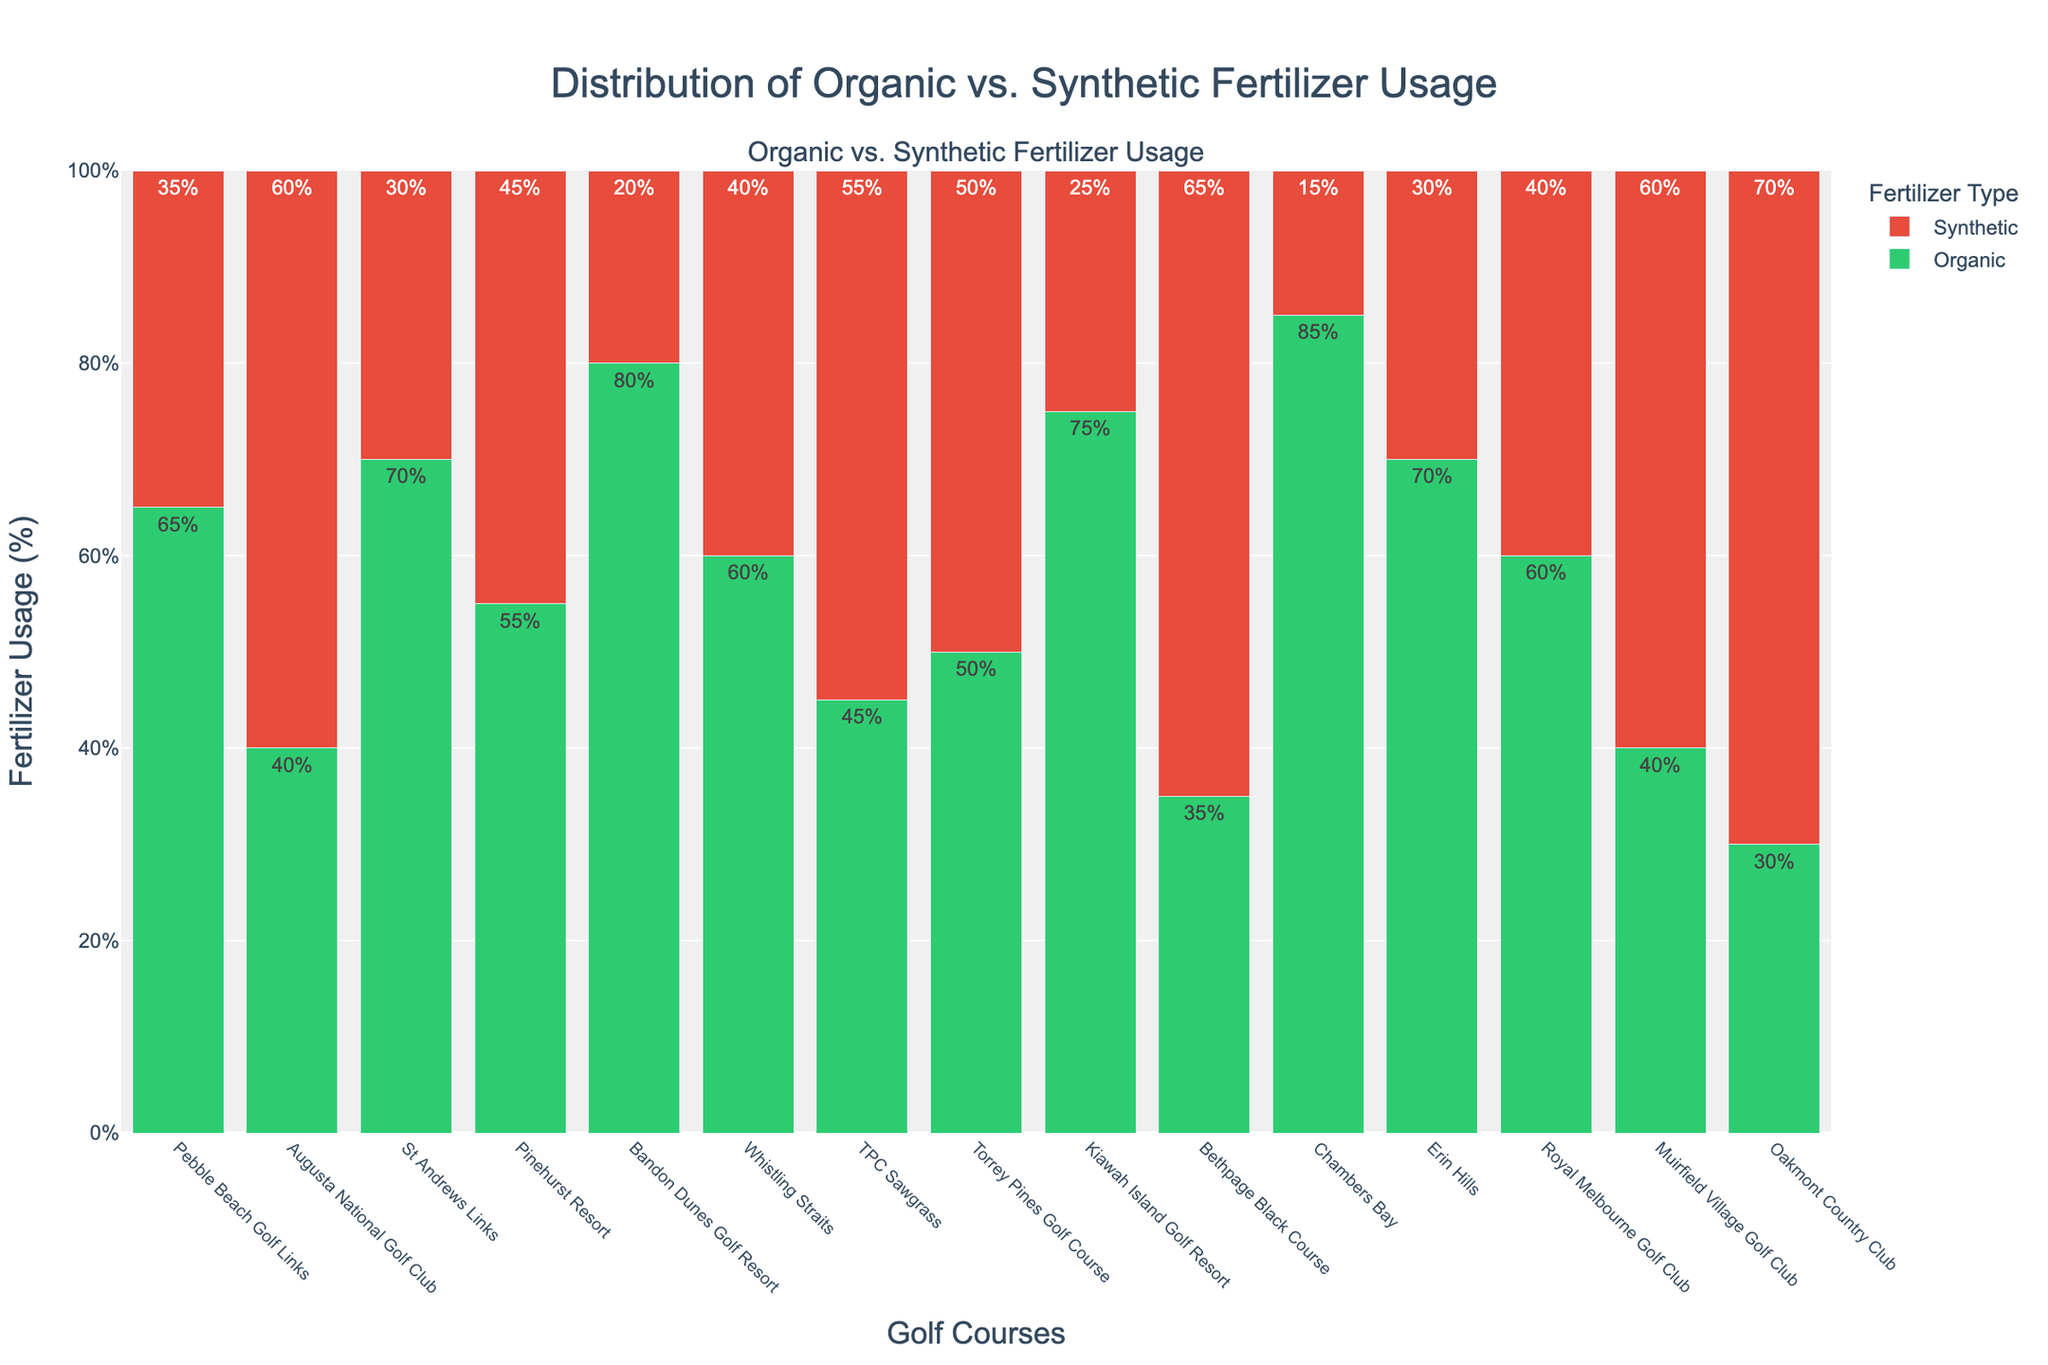What percentage of fertilizer used at Pebble Beach Golf Links is organic? The green bar for Pebble Beach Golf Links indicates that the percentage of organic fertilizer used is 65%.
Answer: 65% Which golf course uses the most synthetic fertilizer? By comparing the height of the red bars, Oakmont Country Club has the tallest red bar, indicating it uses the most synthetic fertilizer at 70%.
Answer: Oakmont Country Club What is the average percentage of organic fertilizer usage across all golf courses? To calculate the average, sum the percentages of organic fertilizer for all courses and divide by the number of courses. The sum is 910%, and there are 15 courses, so 910/15 = 60.67%.
Answer: 60.67% Which golf courses use more synthetic fertilizer than organic? By examining the bars, Augusta National Golf Club, TPC Sawgrass, Torrey Pines Golf Course, Bethpage Black Course, Muirfield Village Golf Club, and Oakmont Country Club have taller red bars than green bars.
Answer: 6 courses How much more organic fertilizer does Chambers Bay use compared to Oakmont Country Club? Chambers Bay uses 85% organic fertilizer, while Oakmont Country Club uses 30%. The difference is 85% - 30% = 55%.
Answer: 55% Which golf course has the highest and lowest usage of organic fertilizer, and what are these percentages? Chambers Bay has the highest usage of organic fertilizer with 85%, and Oakmont Country Club has the lowest with 30%.
Answer: Highest: Chambers Bay (85%); Lowest: Oakmont Country Club (30%) What is the total percentage of synthetic fertilizer used by Pinehurst Resort and Kiawah Island Golf Resort? Pinehurst Resort uses 45% synthetic fertilizer and Kiawah Island Golf Resort uses 25%. The total is 45% + 25% = 70%.
Answer: 70% What is the difference in organic fertilizer usage between St Andrews Links and Erin Hills? St Andrews Links uses 70% organic fertilizer, and Erin Hills also uses 70%. The difference is 70% - 70% = 0%.
Answer: 0% How many golf courses use at least 60% organic fertilizer? By looking at the green bars, Pebble Beach Golf Links, St Andrews Links, Bandon Dunes Golf Resort, Kiawah Island Golf Resort, Chambers Bay, Erin Hills, and Royal Melbourne Golf Club have organic fertilizer usage of 60% or more. There are 7 such courses.
Answer: 7 Which golf courses use exactly 50% organic and 50% synthetic fertilizer? By examining the bars, Torrey Pines Golf Course has equal bars for organic and synthetic fertilizer at 50% each.
Answer: Torrey Pines Golf Course 